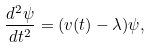Convert formula to latex. <formula><loc_0><loc_0><loc_500><loc_500>\frac { d ^ { 2 } \psi } { d t ^ { 2 } } = ( v ( t ) - \lambda ) \psi ,</formula> 